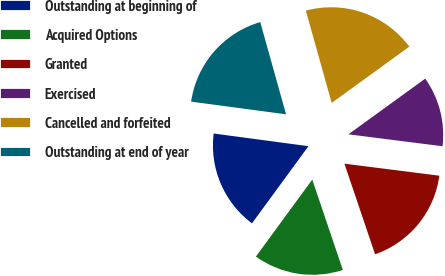Convert chart to OTSL. <chart><loc_0><loc_0><loc_500><loc_500><pie_chart><fcel>Outstanding at beginning of<fcel>Acquired Options<fcel>Granted<fcel>Exercised<fcel>Cancelled and forfeited<fcel>Outstanding at end of year<nl><fcel>17.06%<fcel>15.25%<fcel>17.8%<fcel>11.99%<fcel>19.36%<fcel>18.54%<nl></chart> 